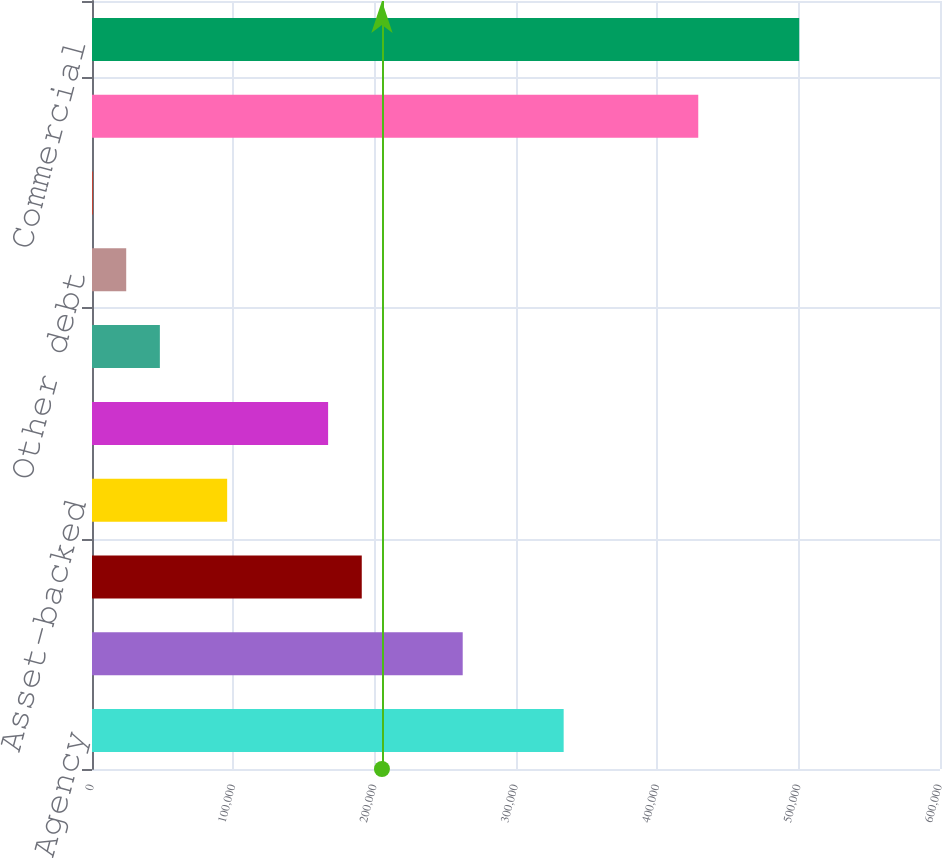<chart> <loc_0><loc_0><loc_500><loc_500><bar_chart><fcel>Agency<fcel>Non-agency<fcel>Commercial mortgage-backed<fcel>Asset-backed<fcel>US Treasury and government<fcel>State and municipal<fcel>Other debt<fcel>Corporate stocks and other<fcel>Total investment securities<fcel>Commercial<nl><fcel>333723<fcel>262296<fcel>190869<fcel>95633.6<fcel>167060<fcel>48015.8<fcel>24206.9<fcel>398<fcel>428958<fcel>500385<nl></chart> 